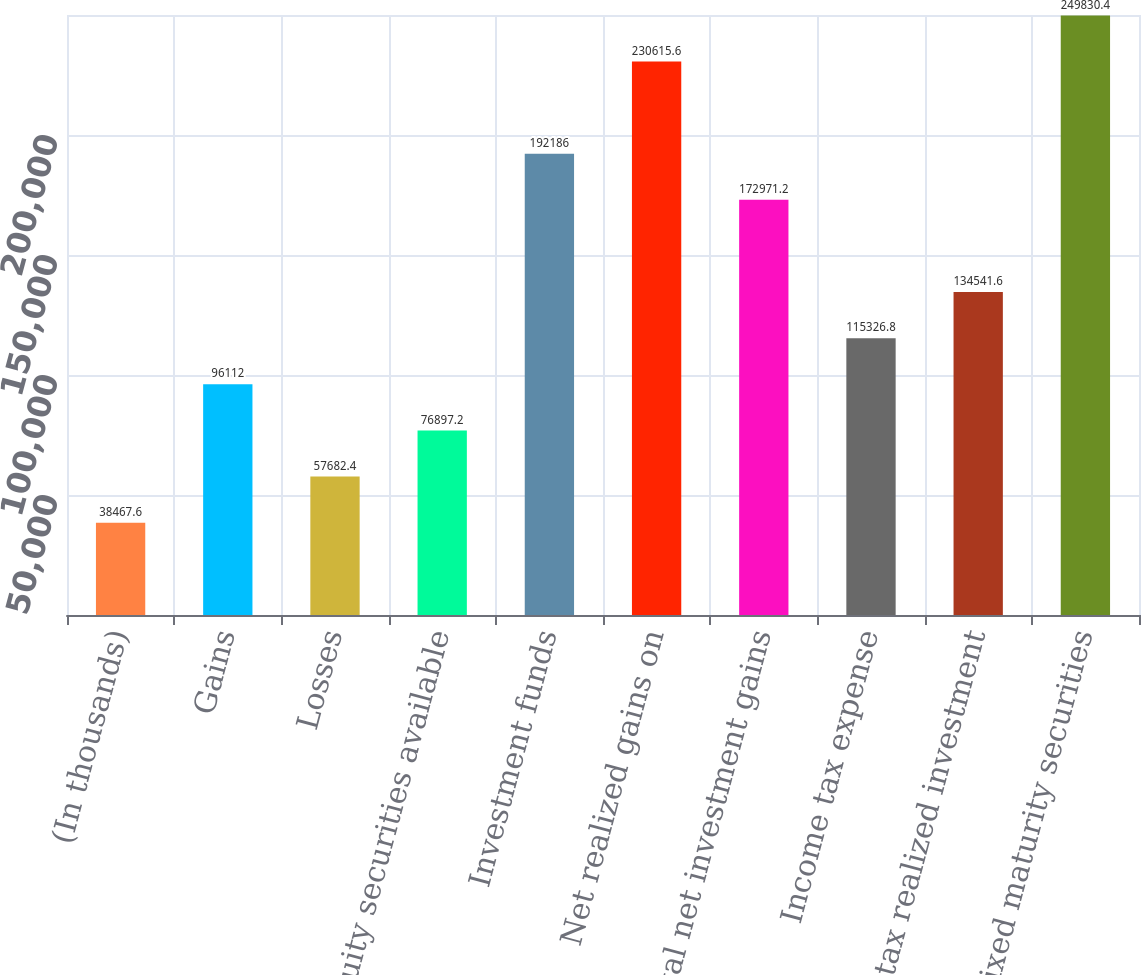<chart> <loc_0><loc_0><loc_500><loc_500><bar_chart><fcel>(In thousands)<fcel>Gains<fcel>Losses<fcel>Equity securities available<fcel>Investment funds<fcel>Net realized gains on<fcel>Total net investment gains<fcel>Income tax expense<fcel>After-tax realized investment<fcel>Fixed maturity securities<nl><fcel>38467.6<fcel>96112<fcel>57682.4<fcel>76897.2<fcel>192186<fcel>230616<fcel>172971<fcel>115327<fcel>134542<fcel>249830<nl></chart> 